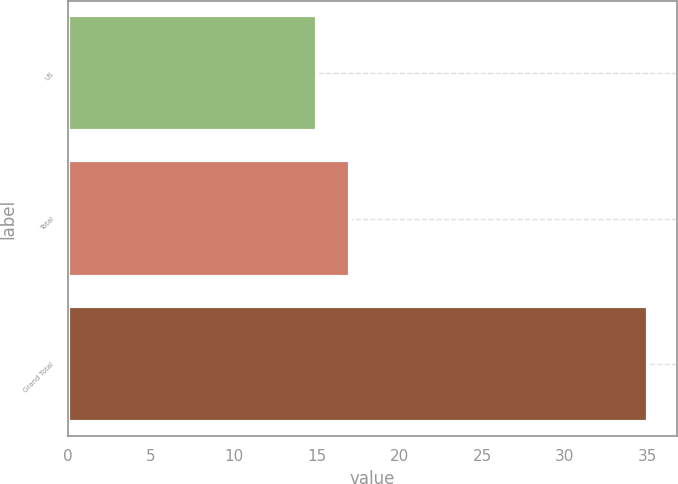Convert chart. <chart><loc_0><loc_0><loc_500><loc_500><bar_chart><fcel>US<fcel>Total<fcel>Grand Total<nl><fcel>15<fcel>17<fcel>35<nl></chart> 